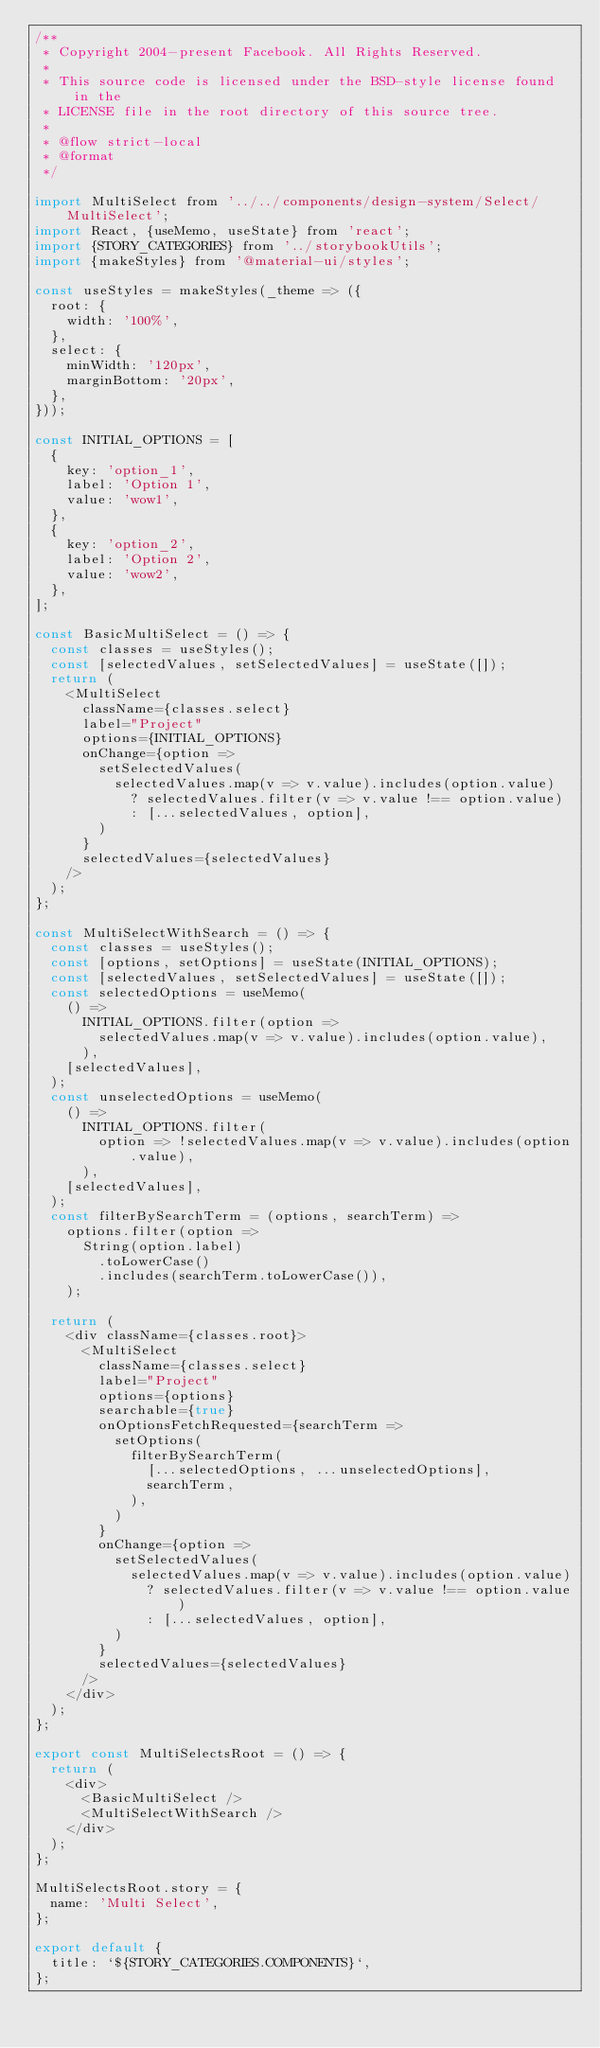<code> <loc_0><loc_0><loc_500><loc_500><_JavaScript_>/**
 * Copyright 2004-present Facebook. All Rights Reserved.
 *
 * This source code is licensed under the BSD-style license found in the
 * LICENSE file in the root directory of this source tree.
 *
 * @flow strict-local
 * @format
 */

import MultiSelect from '../../components/design-system/Select/MultiSelect';
import React, {useMemo, useState} from 'react';
import {STORY_CATEGORIES} from '../storybookUtils';
import {makeStyles} from '@material-ui/styles';

const useStyles = makeStyles(_theme => ({
  root: {
    width: '100%',
  },
  select: {
    minWidth: '120px',
    marginBottom: '20px',
  },
}));

const INITIAL_OPTIONS = [
  {
    key: 'option_1',
    label: 'Option 1',
    value: 'wow1',
  },
  {
    key: 'option_2',
    label: 'Option 2',
    value: 'wow2',
  },
];

const BasicMultiSelect = () => {
  const classes = useStyles();
  const [selectedValues, setSelectedValues] = useState([]);
  return (
    <MultiSelect
      className={classes.select}
      label="Project"
      options={INITIAL_OPTIONS}
      onChange={option =>
        setSelectedValues(
          selectedValues.map(v => v.value).includes(option.value)
            ? selectedValues.filter(v => v.value !== option.value)
            : [...selectedValues, option],
        )
      }
      selectedValues={selectedValues}
    />
  );
};

const MultiSelectWithSearch = () => {
  const classes = useStyles();
  const [options, setOptions] = useState(INITIAL_OPTIONS);
  const [selectedValues, setSelectedValues] = useState([]);
  const selectedOptions = useMemo(
    () =>
      INITIAL_OPTIONS.filter(option =>
        selectedValues.map(v => v.value).includes(option.value),
      ),
    [selectedValues],
  );
  const unselectedOptions = useMemo(
    () =>
      INITIAL_OPTIONS.filter(
        option => !selectedValues.map(v => v.value).includes(option.value),
      ),
    [selectedValues],
  );
  const filterBySearchTerm = (options, searchTerm) =>
    options.filter(option =>
      String(option.label)
        .toLowerCase()
        .includes(searchTerm.toLowerCase()),
    );

  return (
    <div className={classes.root}>
      <MultiSelect
        className={classes.select}
        label="Project"
        options={options}
        searchable={true}
        onOptionsFetchRequested={searchTerm =>
          setOptions(
            filterBySearchTerm(
              [...selectedOptions, ...unselectedOptions],
              searchTerm,
            ),
          )
        }
        onChange={option =>
          setSelectedValues(
            selectedValues.map(v => v.value).includes(option.value)
              ? selectedValues.filter(v => v.value !== option.value)
              : [...selectedValues, option],
          )
        }
        selectedValues={selectedValues}
      />
    </div>
  );
};

export const MultiSelectsRoot = () => {
  return (
    <div>
      <BasicMultiSelect />
      <MultiSelectWithSearch />
    </div>
  );
};

MultiSelectsRoot.story = {
  name: 'Multi Select',
};

export default {
  title: `${STORY_CATEGORIES.COMPONENTS}`,
};
</code> 